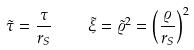Convert formula to latex. <formula><loc_0><loc_0><loc_500><loc_500>\tilde { \tau } = \frac { \tau } { r _ { S } } \quad \tilde { \xi } = \tilde { \varrho } ^ { 2 } = \left ( \frac { \varrho } { r _ { S } } \right ) ^ { 2 }</formula> 